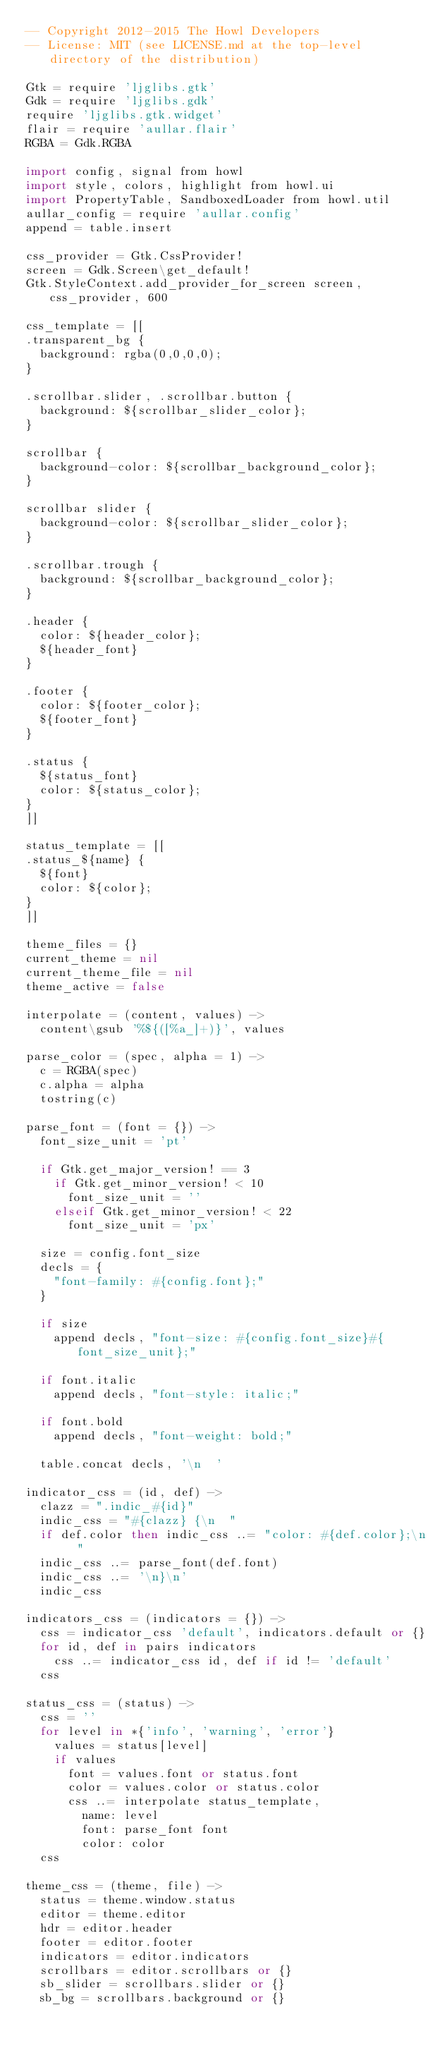<code> <loc_0><loc_0><loc_500><loc_500><_MoonScript_>-- Copyright 2012-2015 The Howl Developers
-- License: MIT (see LICENSE.md at the top-level directory of the distribution)

Gtk = require 'ljglibs.gtk'
Gdk = require 'ljglibs.gdk'
require 'ljglibs.gtk.widget'
flair = require 'aullar.flair'
RGBA = Gdk.RGBA

import config, signal from howl
import style, colors, highlight from howl.ui
import PropertyTable, SandboxedLoader from howl.util
aullar_config = require 'aullar.config'
append = table.insert

css_provider = Gtk.CssProvider!
screen = Gdk.Screen\get_default!
Gtk.StyleContext.add_provider_for_screen screen, css_provider, 600

css_template = [[
.transparent_bg {
  background: rgba(0,0,0,0);
}

.scrollbar.slider, .scrollbar.button {
  background: ${scrollbar_slider_color};
}

scrollbar {
  background-color: ${scrollbar_background_color};
}

scrollbar slider {
  background-color: ${scrollbar_slider_color};
}

.scrollbar.trough {
  background: ${scrollbar_background_color};
}

.header {
  color: ${header_color};
  ${header_font}
}

.footer {
  color: ${footer_color};
  ${footer_font}
}

.status {
  ${status_font}
  color: ${status_color};
}
]]

status_template = [[
.status_${name} {
  ${font}
  color: ${color};
}
]]

theme_files = {}
current_theme = nil
current_theme_file = nil
theme_active = false

interpolate = (content, values) ->
  content\gsub '%${([%a_]+)}', values

parse_color = (spec, alpha = 1) ->
  c = RGBA(spec)
  c.alpha = alpha
  tostring(c)

parse_font = (font = {}) ->
  font_size_unit = 'pt'

  if Gtk.get_major_version! == 3
    if Gtk.get_minor_version! < 10
      font_size_unit = ''
    elseif Gtk.get_minor_version! < 22
      font_size_unit = 'px'

  size = config.font_size
  decls = {
    "font-family: #{config.font};"
  }

  if size
    append decls, "font-size: #{config.font_size}#{font_size_unit};"

  if font.italic
    append decls, "font-style: italic;"

  if font.bold
    append decls, "font-weight: bold;"

  table.concat decls, '\n  '

indicator_css = (id, def) ->
  clazz = ".indic_#{id}"
  indic_css = "#{clazz} {\n  "
  if def.color then indic_css ..= "color: #{def.color};\n  "
  indic_css ..= parse_font(def.font)
  indic_css ..= '\n}\n'
  indic_css

indicators_css = (indicators = {}) ->
  css = indicator_css 'default', indicators.default or {}
  for id, def in pairs indicators
    css ..= indicator_css id, def if id != 'default'
  css

status_css = (status) ->
  css = ''
  for level in *{'info', 'warning', 'error'}
    values = status[level]
    if values
      font = values.font or status.font
      color = values.color or status.color
      css ..= interpolate status_template,
        name: level
        font: parse_font font
        color: color
  css

theme_css = (theme, file) ->
  status = theme.window.status
  editor = theme.editor
  hdr = editor.header
  footer = editor.footer
  indicators = editor.indicators
  scrollbars = editor.scrollbars or {}
  sb_slider = scrollbars.slider or {}
  sb_bg = scrollbars.background or {}</code> 